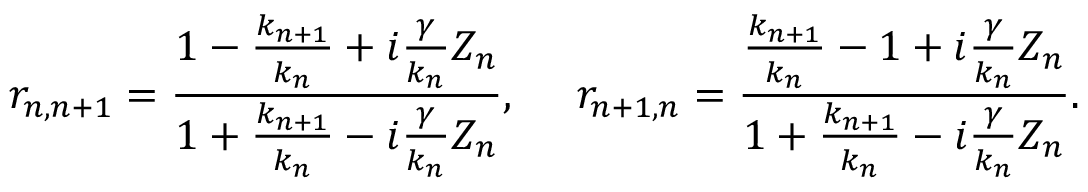<formula> <loc_0><loc_0><loc_500><loc_500>r _ { n , n + 1 } = \frac { 1 - \frac { k _ { n + 1 } } { k _ { n } } + i \frac { \gamma } { k _ { n } } Z _ { n } } { 1 + \frac { k _ { n + 1 } } { k _ { n } } - i \frac { \gamma } { k _ { n } } Z _ { n } } , \quad r _ { n + 1 , n } = \frac { \frac { k _ { n + 1 } } { k _ { n } } - 1 + i \frac { \gamma } { k _ { n } } Z _ { n } } { 1 + \frac { k _ { n + 1 } } { k _ { n } } - i \frac { \gamma } { k _ { n } } Z _ { n } } .</formula> 